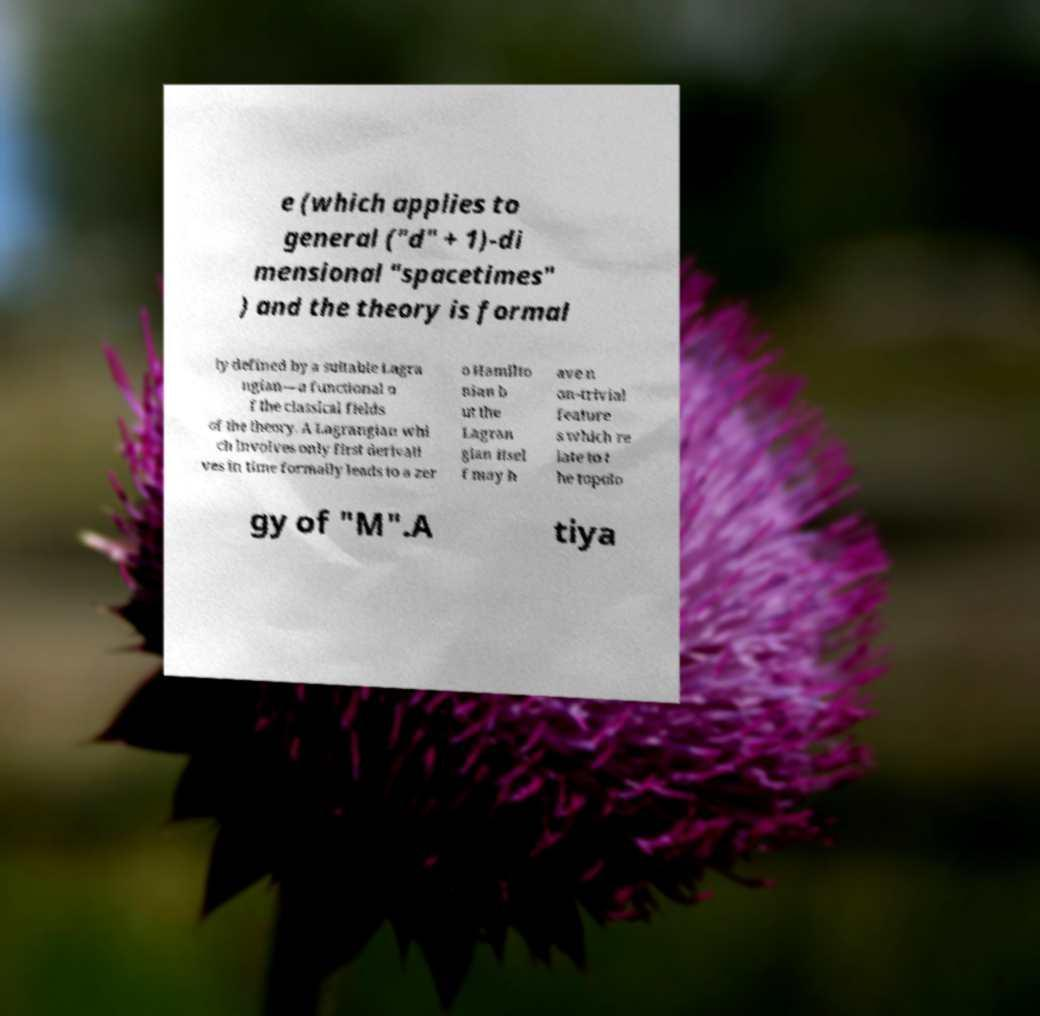Could you extract and type out the text from this image? e (which applies to general ("d" + 1)-di mensional "spacetimes" ) and the theory is formal ly defined by a suitable Lagra ngian—a functional o f the classical fields of the theory. A Lagrangian whi ch involves only first derivati ves in time formally leads to a zer o Hamilto nian b ut the Lagran gian itsel f may h ave n on-trivial feature s which re late to t he topolo gy of "M".A tiya 